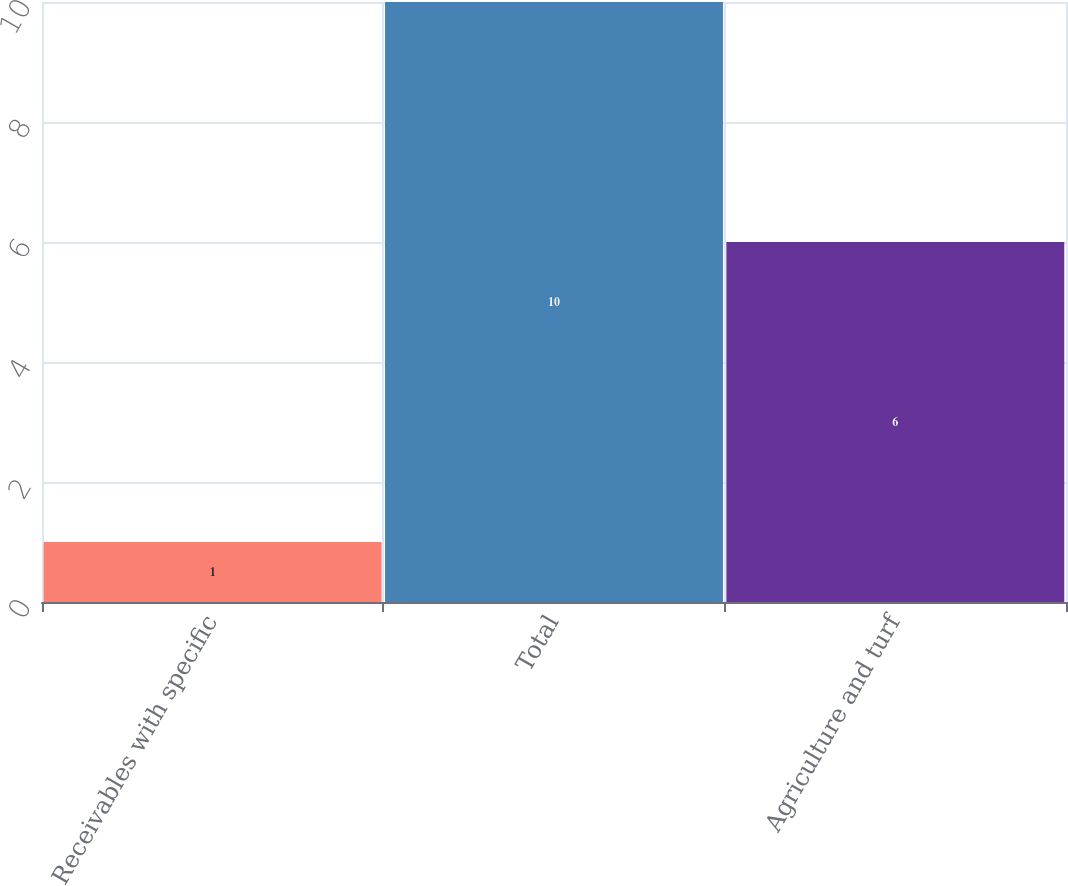<chart> <loc_0><loc_0><loc_500><loc_500><bar_chart><fcel>Receivables with specific<fcel>Total<fcel>Agriculture and turf<nl><fcel>1<fcel>10<fcel>6<nl></chart> 